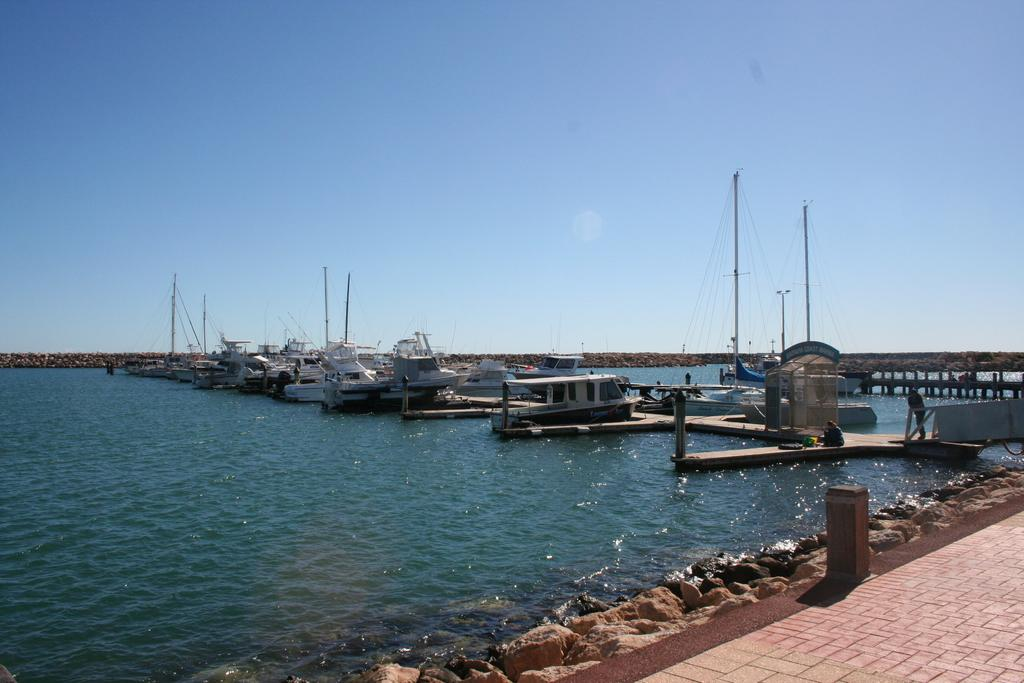What is in the water in the image? There are boats in the water in the image. What type of natural formation can be seen in the image? There are rocks visible in the image. Where are the two persons located in the image? The two persons are in the right corner of the image. What type of butter can be seen melting on the rocks in the image? There is no butter present in the image; it features boats in the water and rocks. 